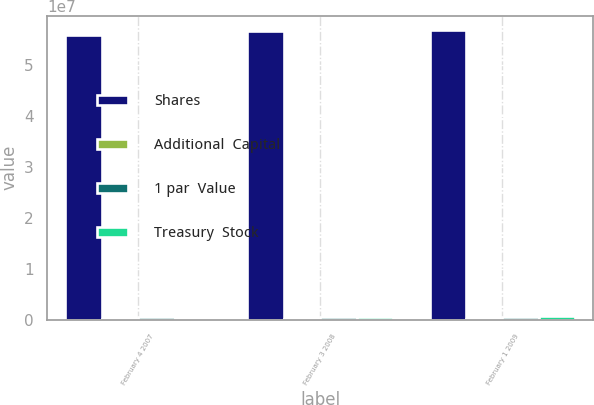<chart> <loc_0><loc_0><loc_500><loc_500><stacked_bar_chart><ecel><fcel>February 4 2007<fcel>February 3 2008<fcel>February 1 2009<nl><fcel>Shares<fcel>5.585e+07<fcel>5.65058e+07<fcel>5.67087e+07<nl><fcel>Additional  Capital<fcel>55850<fcel>56506<fcel>56709<nl><fcel>1 par  Value<fcel>530002<fcel>558960<fcel>573287<nl><fcel>Treasury  Stock<fcel>388555<fcel>558538<fcel>642183<nl></chart> 